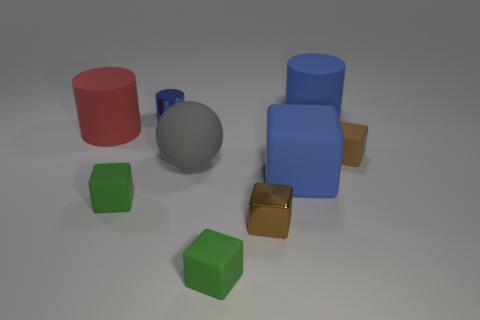There is a block that is the same color as the small cylinder; what is it made of? The block sharing the same blue color as the small cylinder is likely made of rubber. This material is common in educational or children's toys for safety and durability. 